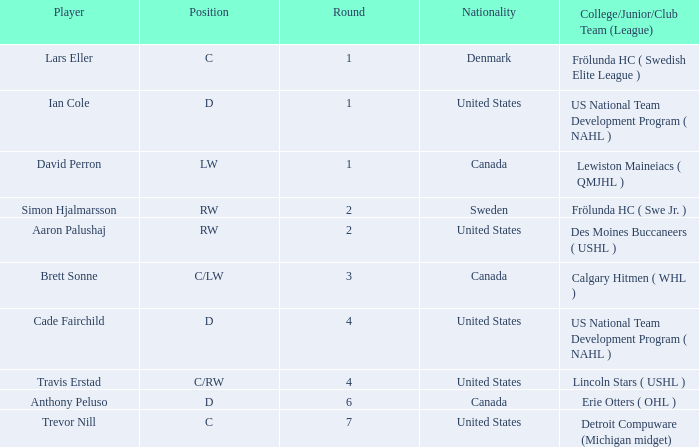What is the position of the player from round 2 from Sweden? RW. Parse the table in full. {'header': ['Player', 'Position', 'Round', 'Nationality', 'College/Junior/Club Team (League)'], 'rows': [['Lars Eller', 'C', '1', 'Denmark', 'Frölunda HC ( Swedish Elite League )'], ['Ian Cole', 'D', '1', 'United States', 'US National Team Development Program ( NAHL )'], ['David Perron', 'LW', '1', 'Canada', 'Lewiston Maineiacs ( QMJHL )'], ['Simon Hjalmarsson', 'RW', '2', 'Sweden', 'Frölunda HC ( Swe Jr. )'], ['Aaron Palushaj', 'RW', '2', 'United States', 'Des Moines Buccaneers ( USHL )'], ['Brett Sonne', 'C/LW', '3', 'Canada', 'Calgary Hitmen ( WHL )'], ['Cade Fairchild', 'D', '4', 'United States', 'US National Team Development Program ( NAHL )'], ['Travis Erstad', 'C/RW', '4', 'United States', 'Lincoln Stars ( USHL )'], ['Anthony Peluso', 'D', '6', 'Canada', 'Erie Otters ( OHL )'], ['Trevor Nill', 'C', '7', 'United States', 'Detroit Compuware (Michigan midget)']]} 